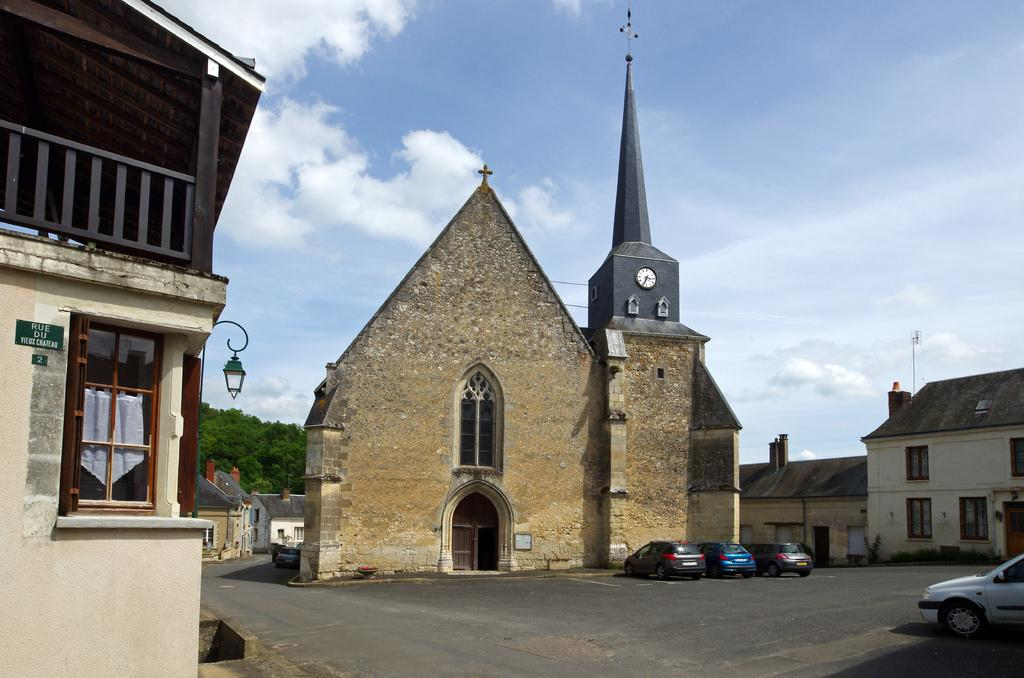What type of structure is located in the middle of the image? There is a clock tower in the image, and it is located in the middle along with a church. What other buildings can be seen in the image? There are many buildings in the area, as mentioned in the facts. How are the cars positioned in the image? Cars are parked on the road in the image. What type of vegetation is visible behind the buildings and parked cars? There are trees visible behind the buildings and parked cars. What type of baseball equipment can be seen in the image? There is no baseball equipment present in the image. Can you tell me which wrist the person in the image is wearing a watch on? There is no person wearing a watch in the image. 